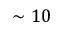<formula> <loc_0><loc_0><loc_500><loc_500>\sim 1 0</formula> 